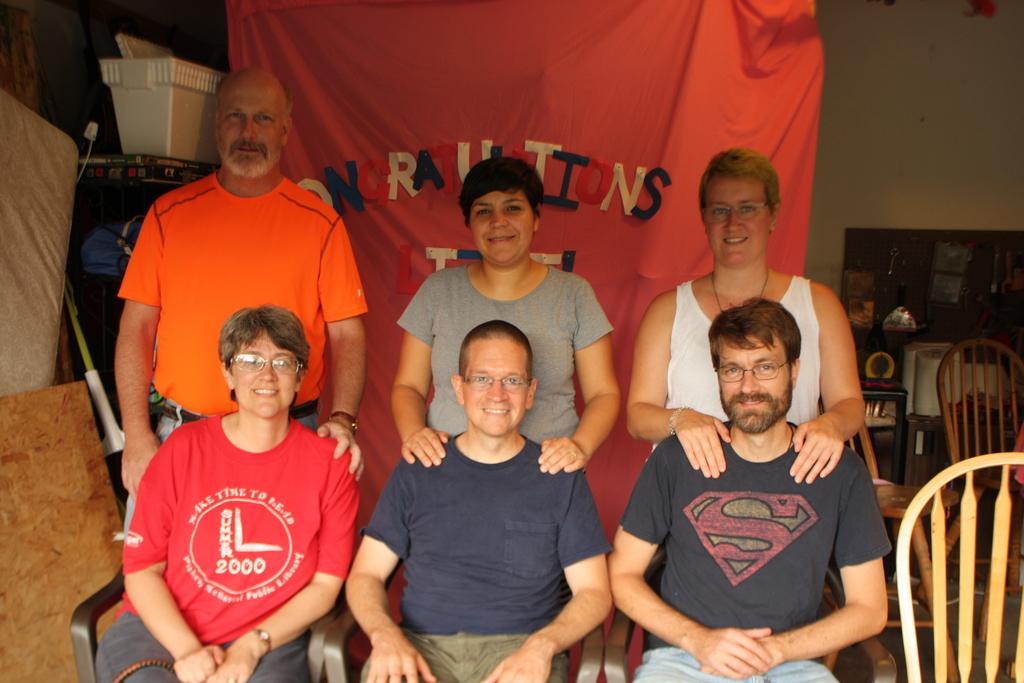Please provide a concise description of this image. In this image I can see three people are sitting and three people are standing. At the back there is a red banner and some name is written on it. At the left some objects are there. And at the right there are some chairs and the wall. 